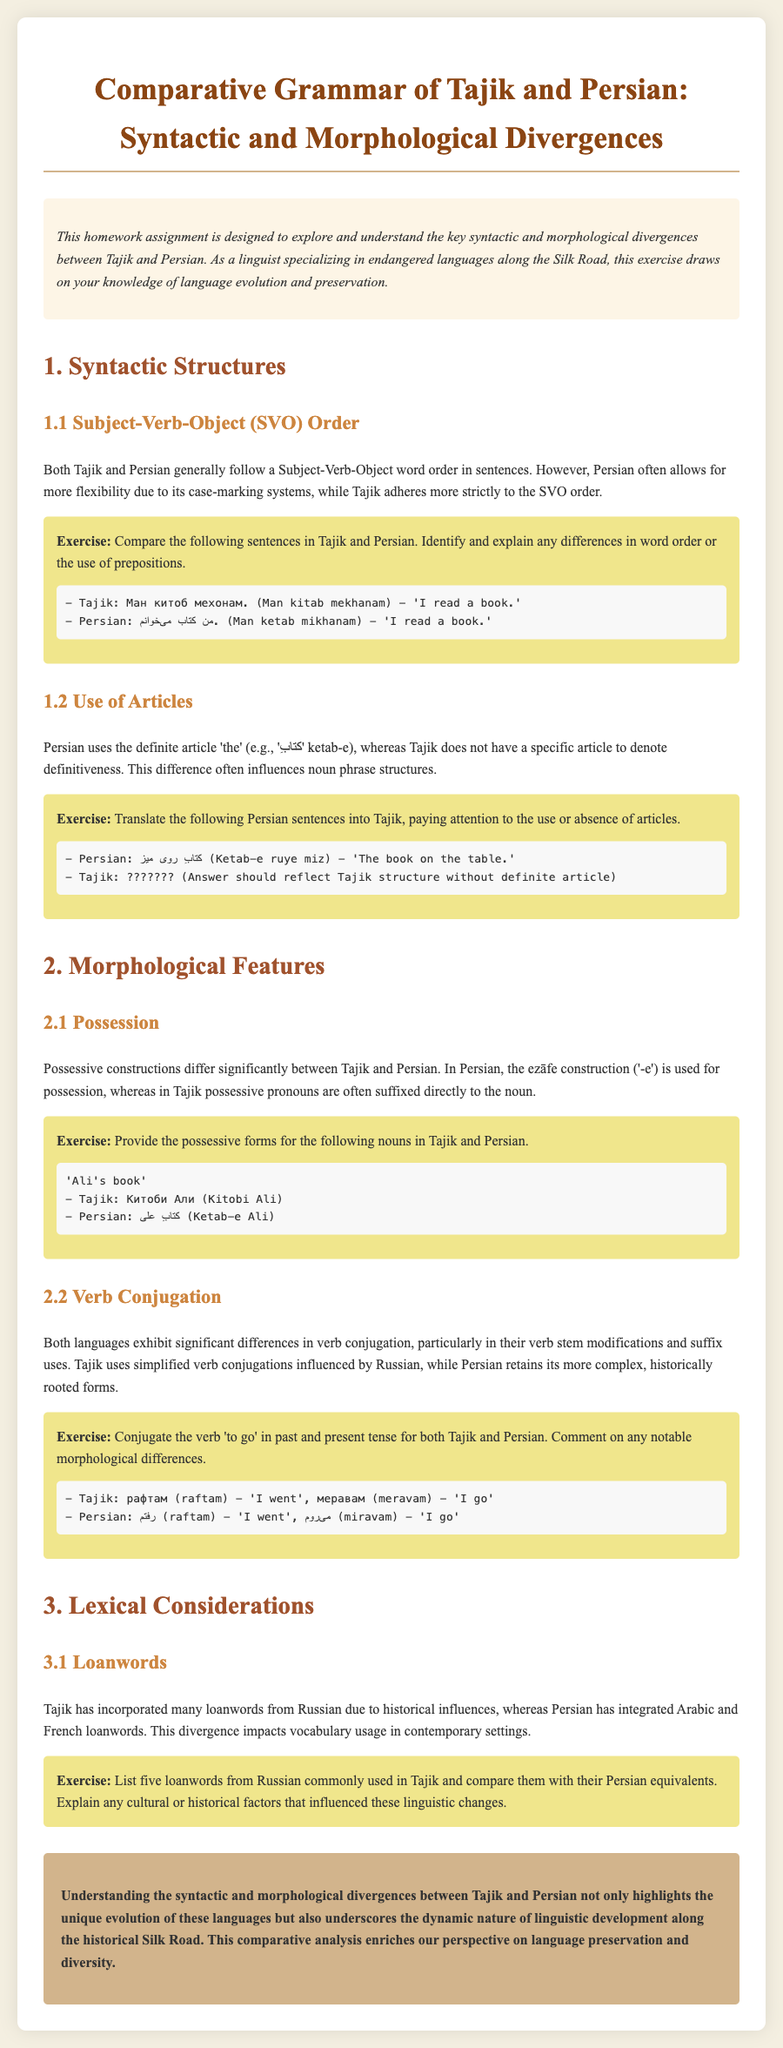What is the title of the document? The title is explicitly stated in the header of the document.
Answer: Comparative Grammar of Tajik and Persian: Syntactic and Morphological Divergences What is a key syntactic feature discussed for both languages? The key syntactic feature mentioned is the word order commonly used in sentences.
Answer: Subject-Verb-Object order How does Tajik handle definite articles? The document specifies how Tajik does not use a specific article to denote definitiveness.
Answer: Does not have a specific article What is the Persian construction for possession called? The document explains a specific term for the possession construction in Persian.
Answer: ezāfe construction How do Tajik verbs differ in conjugation compared to Persian? The document highlights the influence of another language on Tajik's verb conjugation as a note of comparison.
Answer: Influenced by Russian What does the homework exercise ask regarding loanwords? The exercise requests specific information regarding common vocabulary and its origins in different languages.
Answer: List five loanwords What is noted about Persian's historical influences compared to Tajik? The document states the different sources of loanwords that enrich each language.
Answer: Arabic and French loanwords In what tense does "to go" change in Persian? The verb conjugation exercise illustrates how the verb is used across different tenses in the language.
Answer: Present and past tense Which color is used for the title header in the document? The style section specifies color settings that visually represent the title.
Answer: #8b4513 